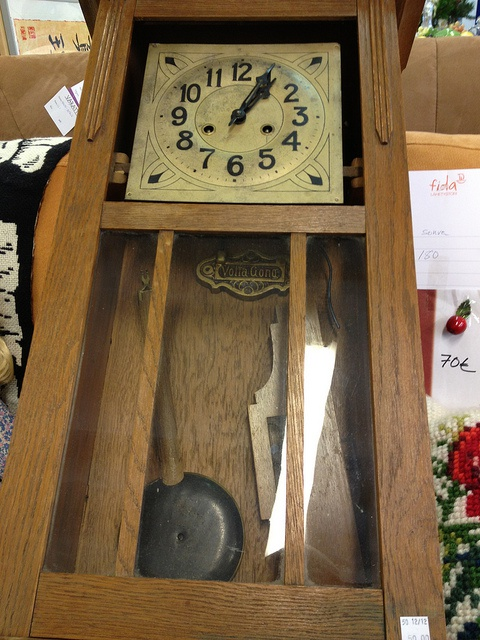Describe the objects in this image and their specific colors. I can see a clock in gray, tan, black, and olive tones in this image. 